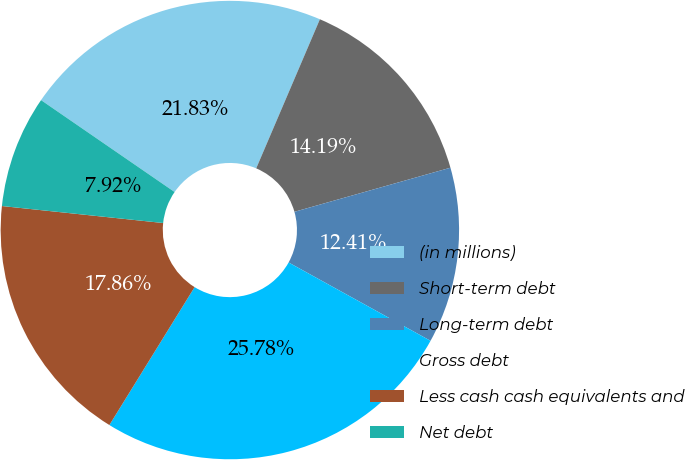Convert chart to OTSL. <chart><loc_0><loc_0><loc_500><loc_500><pie_chart><fcel>(in millions)<fcel>Short-term debt<fcel>Long-term debt<fcel>Gross debt<fcel>Less cash cash equivalents and<fcel>Net debt<nl><fcel>21.83%<fcel>14.19%<fcel>12.41%<fcel>25.78%<fcel>17.86%<fcel>7.92%<nl></chart> 